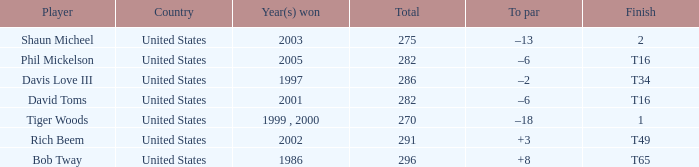What is the to par number of the person who won in 2003? –13. 